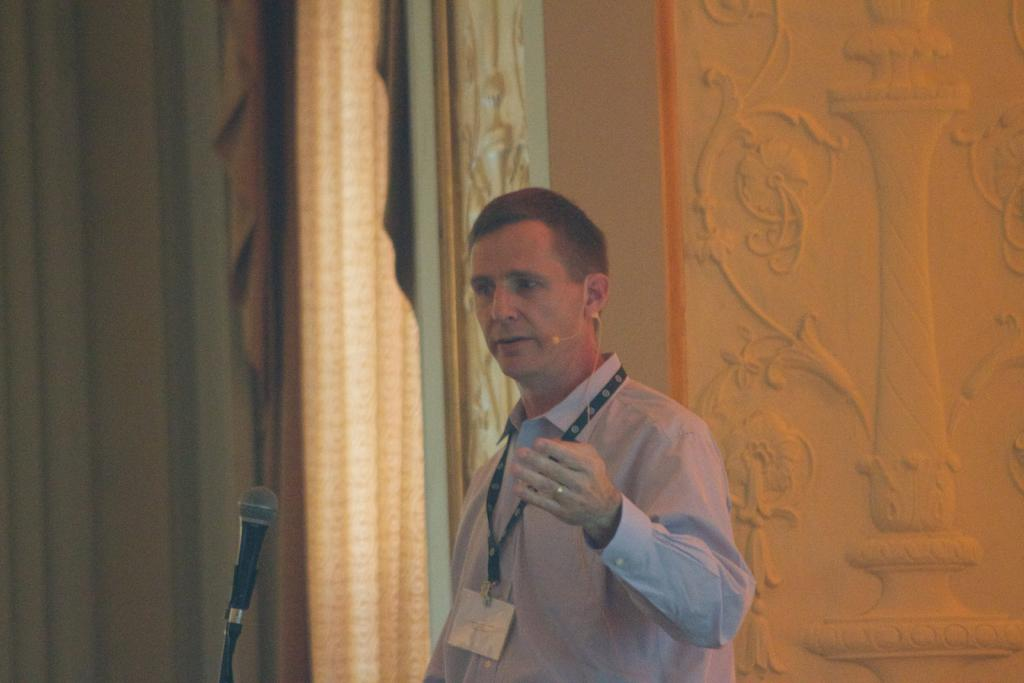What is the man in the image holding? The man is holding a mic. Is there any other equipment related to sound or communication in the image? Yes, there is a microphone on the person's ear. What can be seen in the background of the image? There is a curtain, an object, and a design on the wall in the background of the image. What type of toad can be seen sitting on the man's shoulder in the image? There is no toad present in the image; the man is holding a mic and has a microphone on his ear. What flavor of eggnog is the man drinking in the image? There is no eggnog present in the image; the man is holding a mic and has a microphone on his ear. 